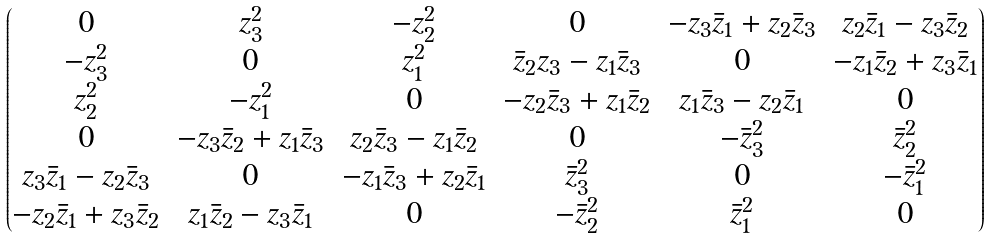Convert formula to latex. <formula><loc_0><loc_0><loc_500><loc_500>\begin{pmatrix} 0 & z _ { 3 } ^ { 2 } & - z _ { 2 } ^ { 2 } & 0 & - z _ { 3 } \bar { z } _ { 1 } + z _ { 2 } \bar { z } _ { 3 } & z _ { 2 } \bar { z } _ { 1 } - z _ { 3 } \bar { z } _ { 2 } \\ - z _ { 3 } ^ { 2 } & 0 & z _ { 1 } ^ { 2 } & \bar { z } _ { 2 } z _ { 3 } - z _ { 1 } \bar { z } _ { 3 } & 0 & - z _ { 1 } \bar { z } _ { 2 } + z _ { 3 } \bar { z } _ { 1 } \\ z _ { 2 } ^ { 2 } & - z _ { 1 } ^ { 2 } & 0 & - z _ { 2 } \bar { z } _ { 3 } + z _ { 1 } \bar { z } _ { 2 } & z _ { 1 } \bar { z } _ { 3 } - z _ { 2 } \bar { z } _ { 1 } & 0 \\ 0 & - z _ { 3 } \bar { z } _ { 2 } + z _ { 1 } \bar { z } _ { 3 } & z _ { 2 } \bar { z } _ { 3 } - z _ { 1 } \bar { z } _ { 2 } & 0 & - \bar { z } _ { 3 } ^ { 2 } & \bar { z } _ { 2 } ^ { 2 } \\ z _ { 3 } \bar { z } _ { 1 } - z _ { 2 } \bar { z } _ { 3 } & 0 & - z _ { 1 } \bar { z } _ { 3 } + z _ { 2 } \bar { z } _ { 1 } & \bar { z } _ { 3 } ^ { 2 } & 0 & - \bar { z } _ { 1 } ^ { 2 } \\ - z _ { 2 } \bar { z } _ { 1 } + z _ { 3 } \bar { z } _ { 2 } & z _ { 1 } \bar { z } _ { 2 } - z _ { 3 } \bar { z } _ { 1 } & 0 & - \bar { z } _ { 2 } ^ { 2 } & \bar { z } _ { 1 } ^ { 2 } & 0 \end{pmatrix}</formula> 